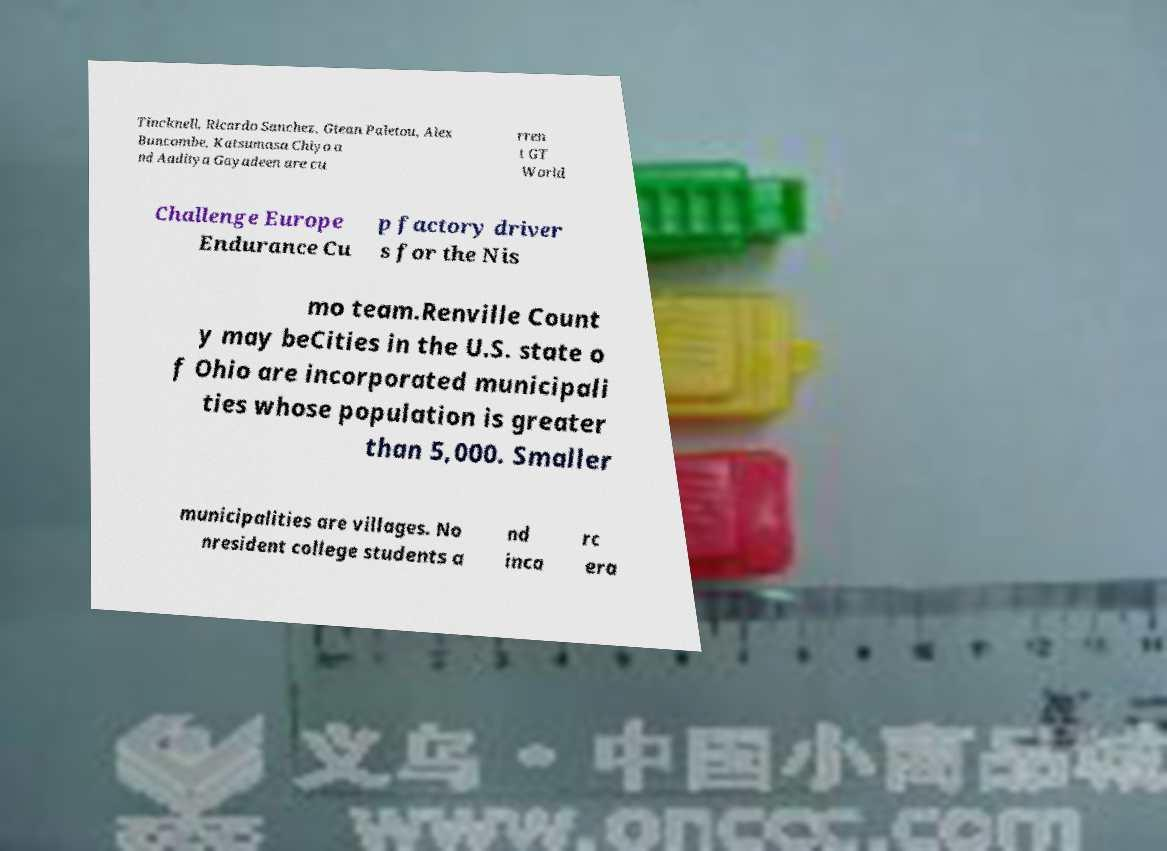Could you assist in decoding the text presented in this image and type it out clearly? Tincknell, Ricardo Sanchez, Gtean Paletou, Alex Buncombe, Katsumasa Chiyo a nd Aaditya Gayadeen are cu rren t GT World Challenge Europe Endurance Cu p factory driver s for the Nis mo team.Renville Count y may beCities in the U.S. state o f Ohio are incorporated municipali ties whose population is greater than 5,000. Smaller municipalities are villages. No nresident college students a nd inca rc era 